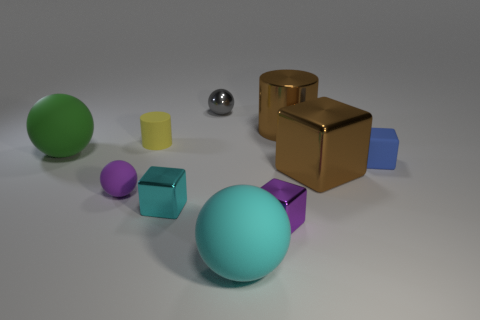Is the size of the shiny block that is on the right side of the purple cube the same as the purple rubber sphere?
Provide a succinct answer. No. What color is the tiny matte ball?
Offer a very short reply. Purple. What color is the large sphere in front of the large matte thing that is left of the small gray metal ball?
Give a very brief answer. Cyan. Is there a small cyan block that has the same material as the purple cube?
Your answer should be compact. Yes. What material is the small object on the right side of the cylinder behind the small yellow rubber cylinder?
Offer a terse response. Rubber. What number of small green matte things have the same shape as the big cyan thing?
Your answer should be compact. 0. What is the shape of the large green thing?
Offer a very short reply. Sphere. Is the number of gray balls less than the number of big green shiny cubes?
Keep it short and to the point. No. Is there any other thing that is the same size as the blue rubber block?
Your response must be concise. Yes. There is a big thing that is the same shape as the small blue matte thing; what is its material?
Provide a succinct answer. Metal. 